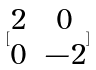<formula> <loc_0><loc_0><loc_500><loc_500>[ \begin{matrix} 2 & 0 \\ 0 & - 2 \end{matrix} ]</formula> 